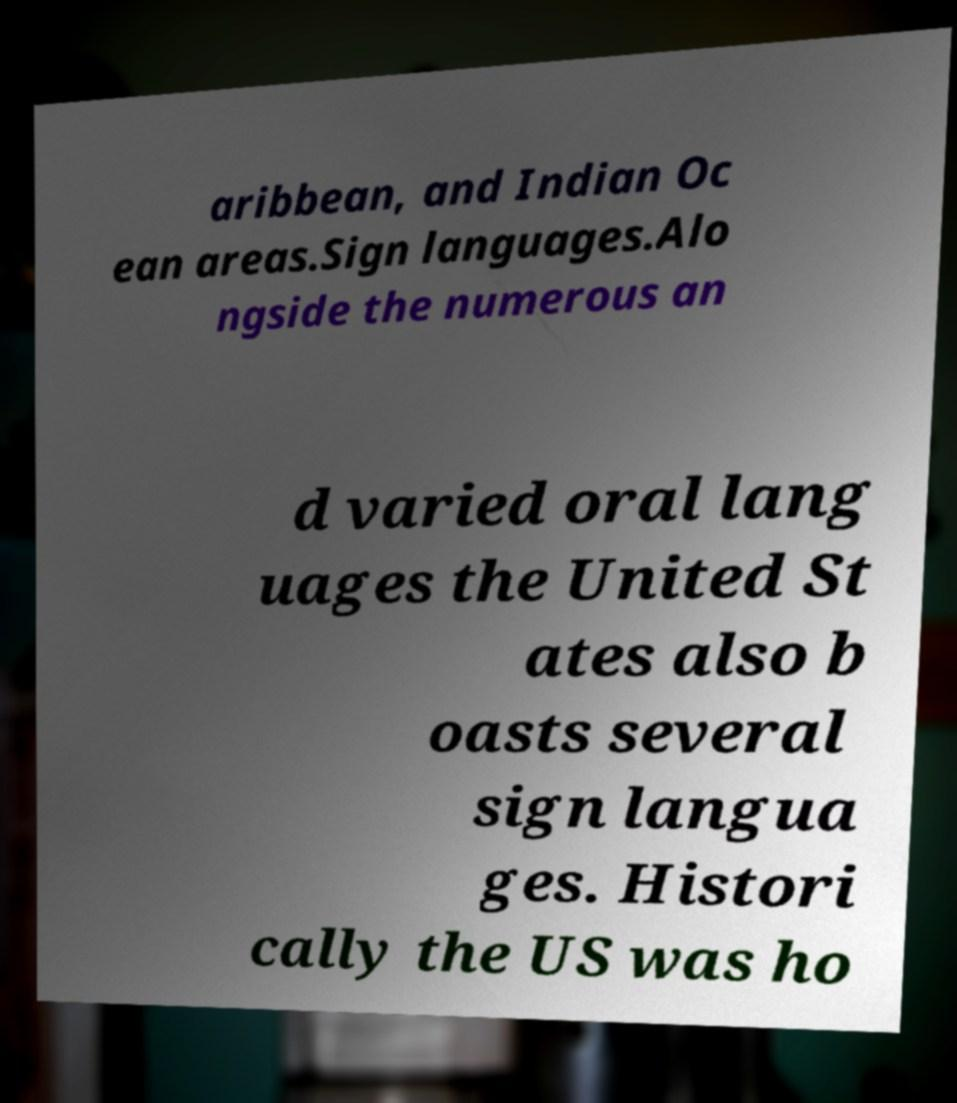I need the written content from this picture converted into text. Can you do that? aribbean, and Indian Oc ean areas.Sign languages.Alo ngside the numerous an d varied oral lang uages the United St ates also b oasts several sign langua ges. Histori cally the US was ho 